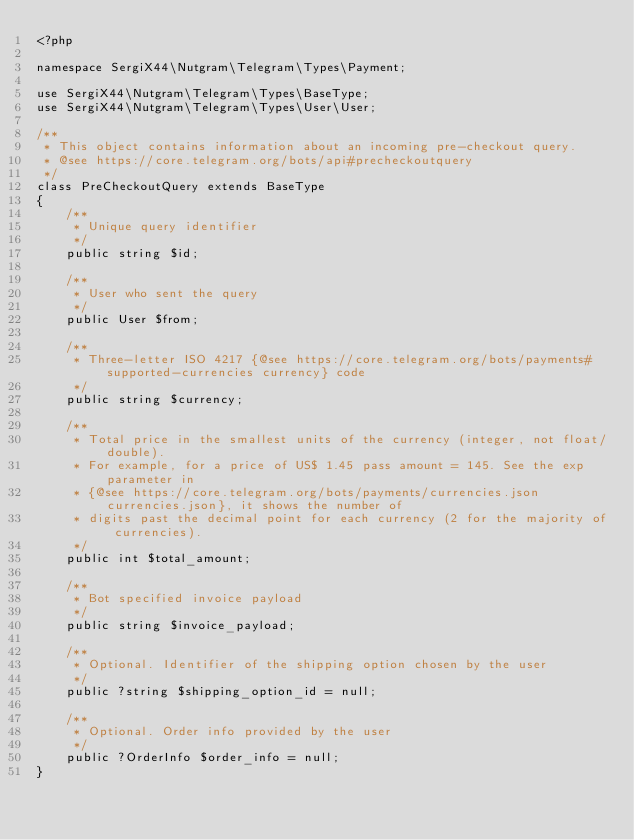<code> <loc_0><loc_0><loc_500><loc_500><_PHP_><?php

namespace SergiX44\Nutgram\Telegram\Types\Payment;

use SergiX44\Nutgram\Telegram\Types\BaseType;
use SergiX44\Nutgram\Telegram\Types\User\User;

/**
 * This object contains information about an incoming pre-checkout query.
 * @see https://core.telegram.org/bots/api#precheckoutquery
 */
class PreCheckoutQuery extends BaseType
{
    /**
     * Unique query identifier
     */
    public string $id;

    /**
     * User who sent the query
     */
    public User $from;

    /**
     * Three-letter ISO 4217 {@see https://core.telegram.org/bots/payments#supported-currencies currency} code
     */
    public string $currency;

    /**
     * Total price in the smallest units of the currency (integer, not float/double).
     * For example, for a price of US$ 1.45 pass amount = 145. See the exp parameter in
     * {@see https://core.telegram.org/bots/payments/currencies.json currencies.json}, it shows the number of
     * digits past the decimal point for each currency (2 for the majority of currencies).
     */
    public int $total_amount;

    /**
     * Bot specified invoice payload
     */
    public string $invoice_payload;

    /**
     * Optional. Identifier of the shipping option chosen by the user
     */
    public ?string $shipping_option_id = null;

    /**
     * Optional. Order info provided by the user
     */
    public ?OrderInfo $order_info = null;
}
</code> 